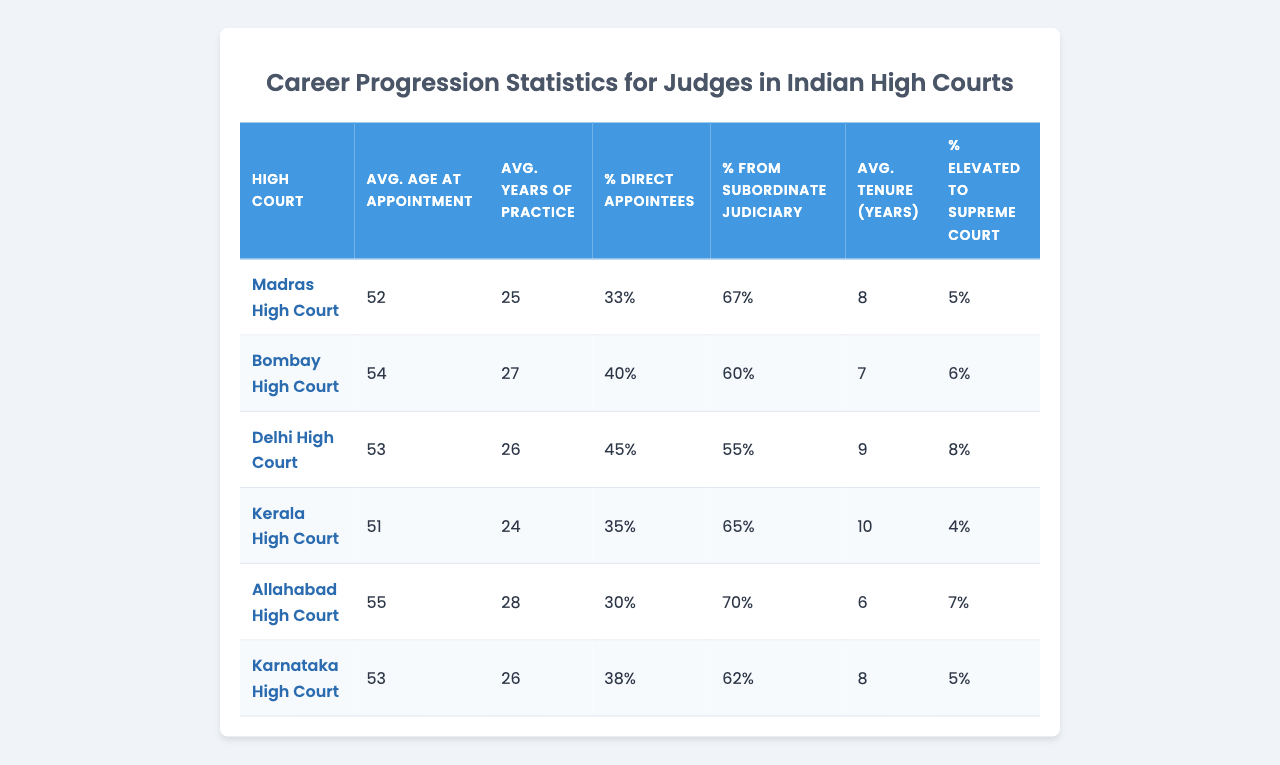What is the average age at appointment for judges in the Madras High Court? The table lists the average age at appointment for the Madras High Court as 52 years.
Answer: 52 How many years of practice do judges in the Allahabad High Court have on average before appointment? According to the table, judges in the Allahabad High Court average 28 years of practice before their appointment.
Answer: 28 What percentage of judges in the Delhi High Court are direct appointees? The table indicates that in the Delhi High Court, 45% of judges are direct appointees.
Answer: 45% Which High Court has the highest average tenure for its judges? The data shows that the Kerala High Court has the highest average tenure for judges at 10 years.
Answer: Kerala High Court Is the percentage of judges elevated to the Supreme Court in the Karnataka High Court higher than 5%? The table states that the percentage elevated to the Supreme Court from the Karnataka High Court is 5%, which is not higher.
Answer: No What is the average age at appointment for judges from the Bombay High Court compared to those from the Kerala High Court? The average age at appointment for the Bombay High Court is 54, while for the Kerala High Court it is 51, indicating that judges in the Bombay High Court are on average older at their appointment.
Answer: 54 (Bombay High Court), 51 (Kerala High Court) What is the difference in average years of practice before appointment between judges in the Allahabad and Madras High Courts? Judges in the Allahabad High Court average 28 years of practice, while those in the Madras High Court average 25 years; thus, the difference is 3 years more for Allahabad judges.
Answer: 3 years Which High Court has a higher percentage of judges coming from the subordinate judiciary: Delhi High Court or Karnataka High Court? The Delhi High Court has 55% of judges from the subordinate judiciary, whereas the Karnataka High Court has 62%; hence, Karnataka has a higher percentage.
Answer: Karnataka High Court What is the average tenure of judges in the Bombay High Court and how does it compare to the average tenure in the Delhi High Court? The average tenure for judges in the Bombay High Court is 7 years, while the average for the Delhi High Court is 9 years. Hence, Delhi High Court judges have a longer average tenure.
Answer: 9 years (Delhi), 7 years (Bombay) If a judge at the Delhi High Court has an average practice of 26 years, how does this compare to the Kerala High Court's average practice? The average years of practice before appointment for judges in Delhi is 26 years, compared to 24 years in Kerala, meaning judges in Delhi have 2 years more on average.
Answer: 2 years more in Delhi What proportion of judges are elevated to the Supreme Court from the Madras High Court? The table specifies that 5% of judges from the Madras High Court are elevated to the Supreme Court.
Answer: 5% 